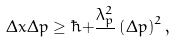Convert formula to latex. <formula><loc_0><loc_0><loc_500><loc_500>\Delta x \Delta p \geq \hbar { + } \frac { \lambda _ { p } ^ { 2 } } { } \left ( \Delta p \right ) ^ { 2 } ,</formula> 